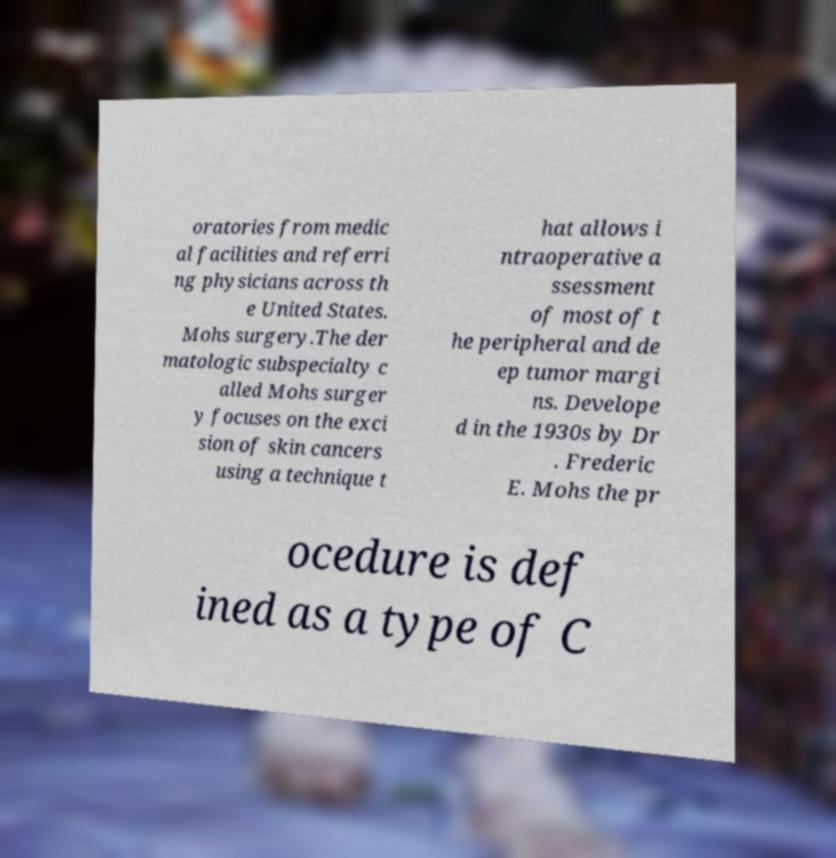For documentation purposes, I need the text within this image transcribed. Could you provide that? oratories from medic al facilities and referri ng physicians across th e United States. Mohs surgery.The der matologic subspecialty c alled Mohs surger y focuses on the exci sion of skin cancers using a technique t hat allows i ntraoperative a ssessment of most of t he peripheral and de ep tumor margi ns. Develope d in the 1930s by Dr . Frederic E. Mohs the pr ocedure is def ined as a type of C 